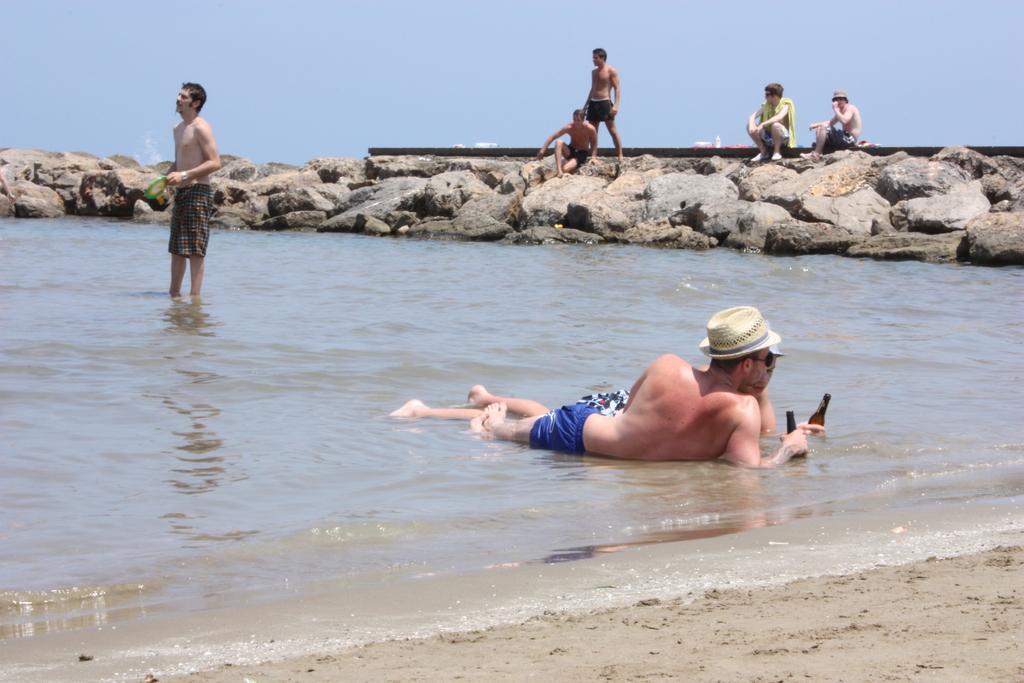How would you summarize this image in a sentence or two? In this picture we can see two people holding bottles in their hands and lying in the water. We can see a man holding a Frisbee in his hand and standing in the water. There are four people, some objects and a few stones are visible from left to right. We can see the sky on top of the picture. 